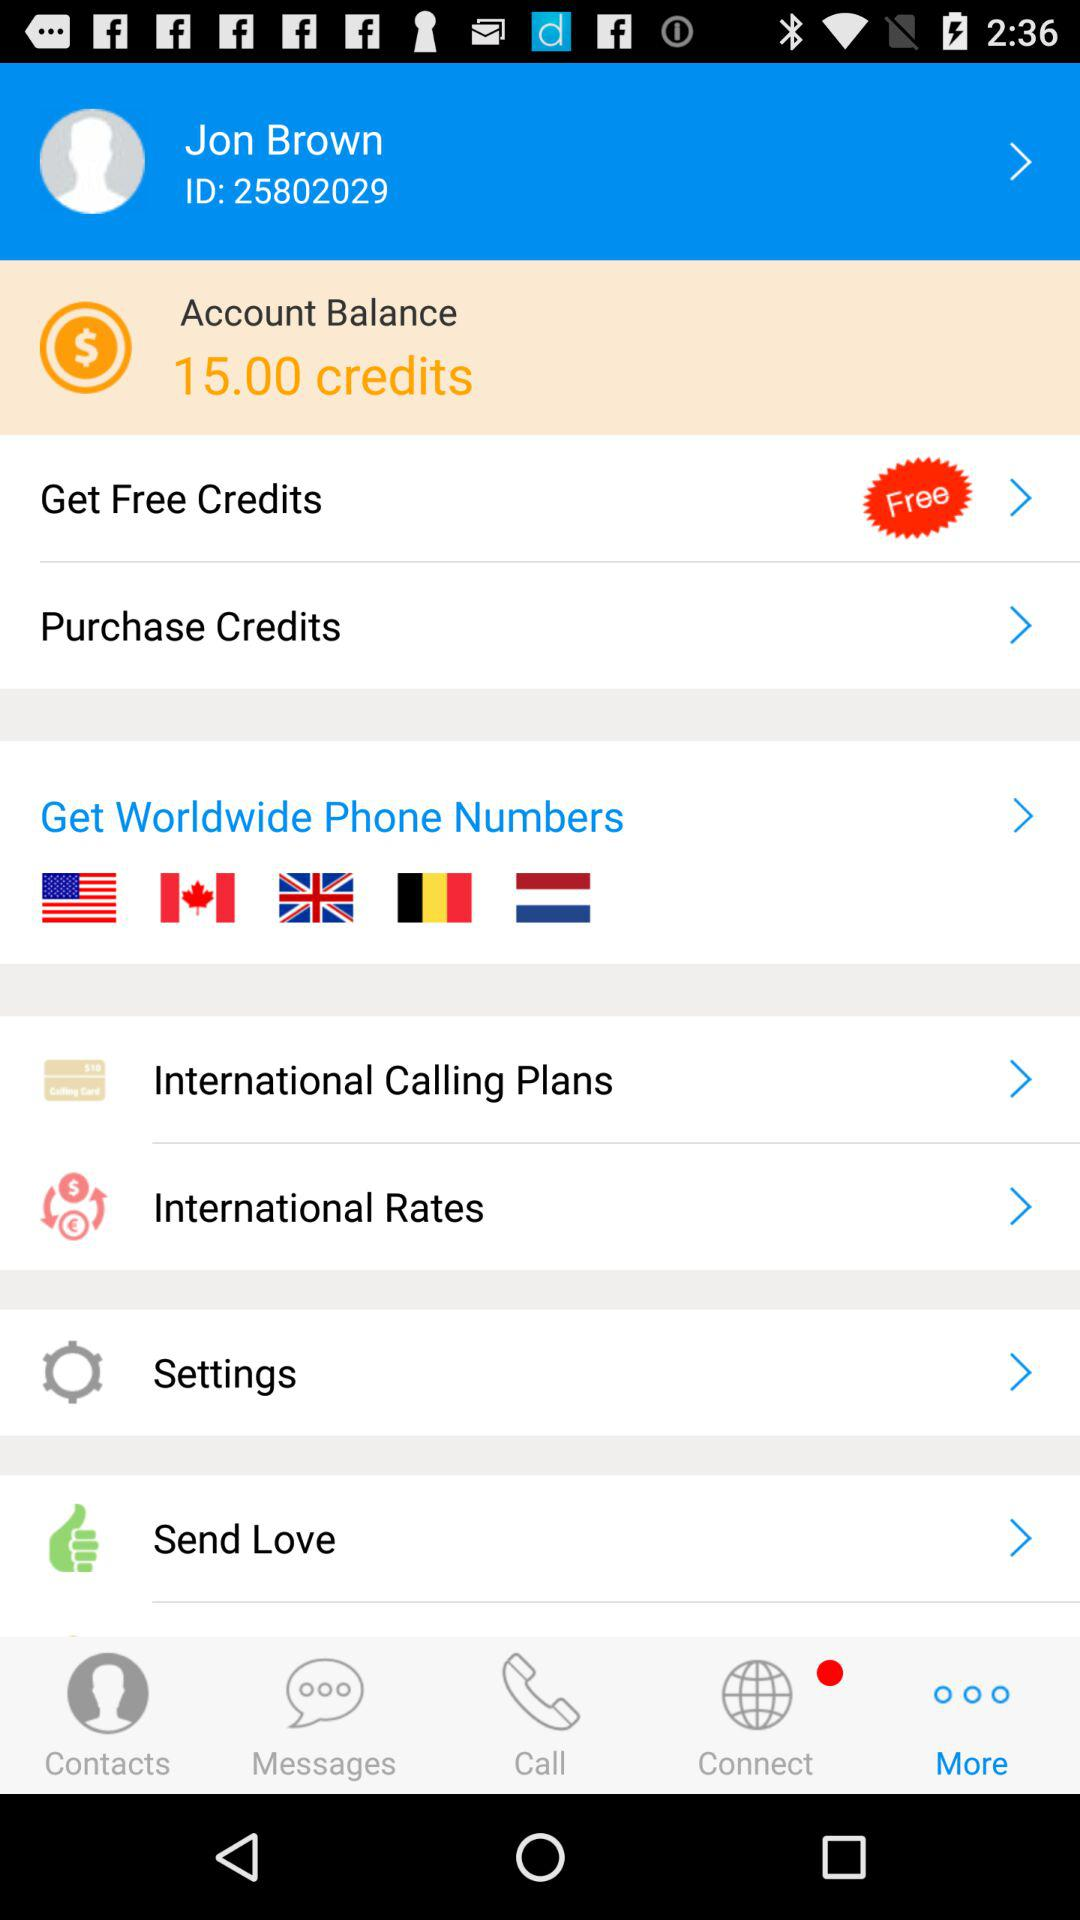Which payment methods can you use to purchase credits?
When the provided information is insufficient, respond with <no answer>. <no answer> 